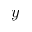<formula> <loc_0><loc_0><loc_500><loc_500>y</formula> 